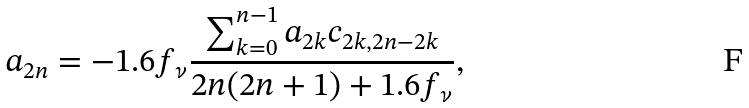Convert formula to latex. <formula><loc_0><loc_0><loc_500><loc_500>a _ { 2 n } = - 1 . 6 f _ { \nu } \frac { \sum _ { k = 0 } ^ { n - 1 } a _ { 2 k } c _ { 2 k , 2 n - 2 k } } { 2 n ( 2 n + 1 ) + 1 . 6 f _ { \nu } } ,</formula> 